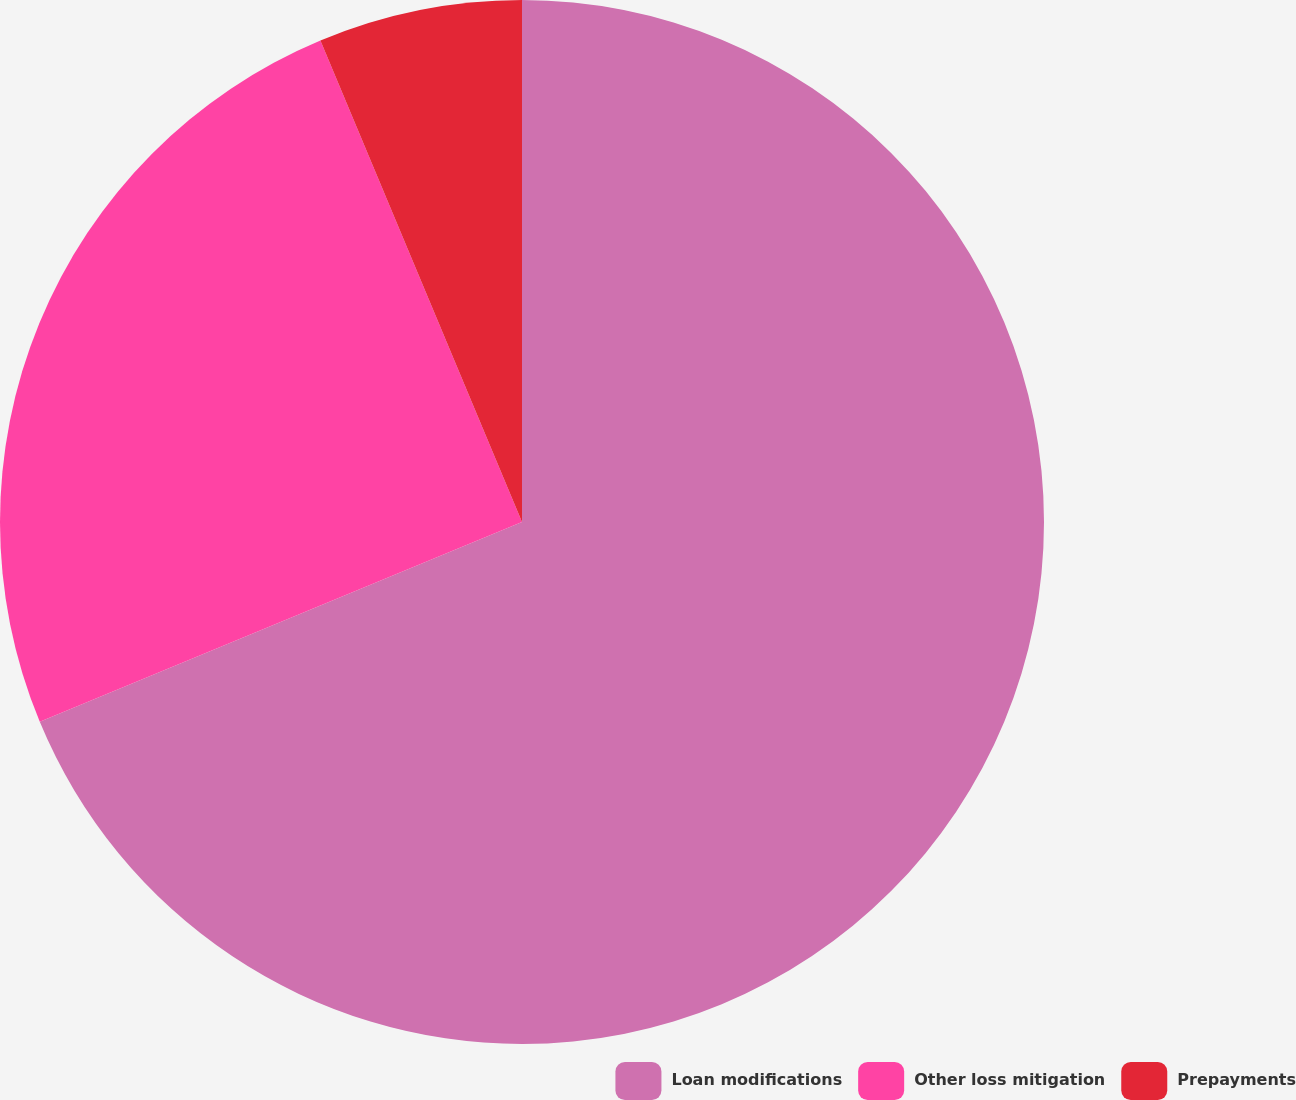Convert chart to OTSL. <chart><loc_0><loc_0><loc_500><loc_500><pie_chart><fcel>Loan modifications<fcel>Other loss mitigation<fcel>Prepayments<nl><fcel>68.74%<fcel>24.94%<fcel>6.31%<nl></chart> 